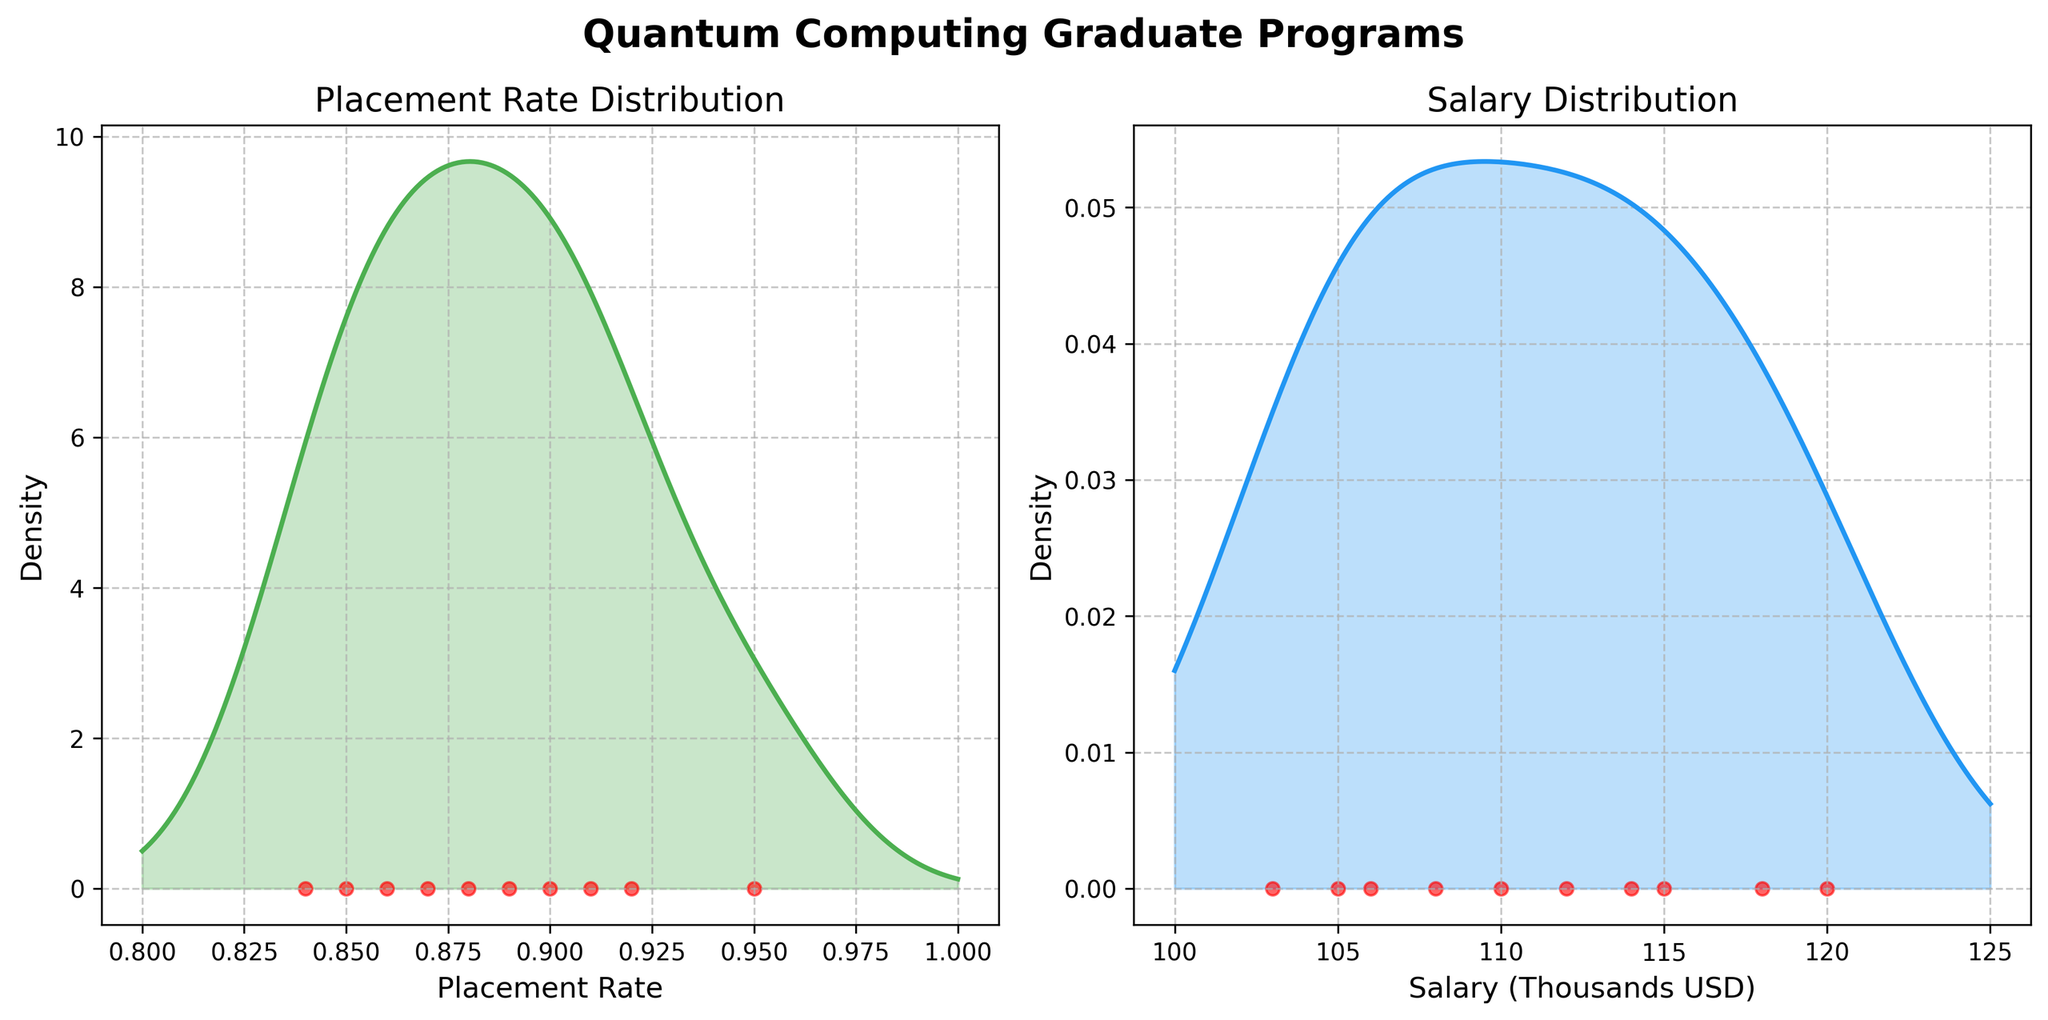what is the title of the first subplot? The first subplot title is shown at the top of the first plot. It reads "Placement Rate Distribution".
Answer: Placement Rate Distribution how many data points are present in each subplot? Each subplot shows individual data points marked as red dots along the horizontal axis. By counting them, we see there are 10 data points in each plot.
Answer: 10 which program has the highest placement rate? Each data point represents a program's placement rate. The red dot furthest to the right on the placement rate subplot corresponds to MIT with a rate of 0.95.
Answer: MIT what range do the placement rates cover? The density plot for placement rates spans horizontally. The x-axis indicates placement rates range from 0.8 to 1.0.
Answer: 0.8 to 1.0 which plot shows a density estimate for salary? The x-axis labels help in identifying the plot related to salary. The second subplot is labeled "Salary (Thousands USD)".
Answer: Second subplot what is the highest value represented on the x-axis of the salary subplot? Observing the x-axis, the maximum value displayed for salary in thousands is 125.
Answer: 125 how does the distribution of salaries compare to placement rates? By examining the density curves, we notice the salary distribution is more spread out, while the placement rate distribution is more concentrated towards the higher end.
Answer: Salaries are more spread out which subplot shows a higher density of data points towards the right? Both subplots exhibit density plots, but the first subplot (placement rate) shows a higher density to the right, indicating higher concentration of high placement rates.
Answer: Placement rate subplot what can you infer about the placement rates' clustering? The placement rate density plot peaks significantly towards the higher values, suggesting most programs have high placement rates.
Answer: High placement rates clustering are placement rates generally higher or lower than salaries in thousands? The x-axis scale comparison shows that placement rates mostly fall between 0.85 and 0.95, indicating higher consistency, while salaries vary more, between 100 to 125 thousand USD.
Answer: Placement rates generally higher in consistency 